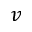<formula> <loc_0><loc_0><loc_500><loc_500>v</formula> 